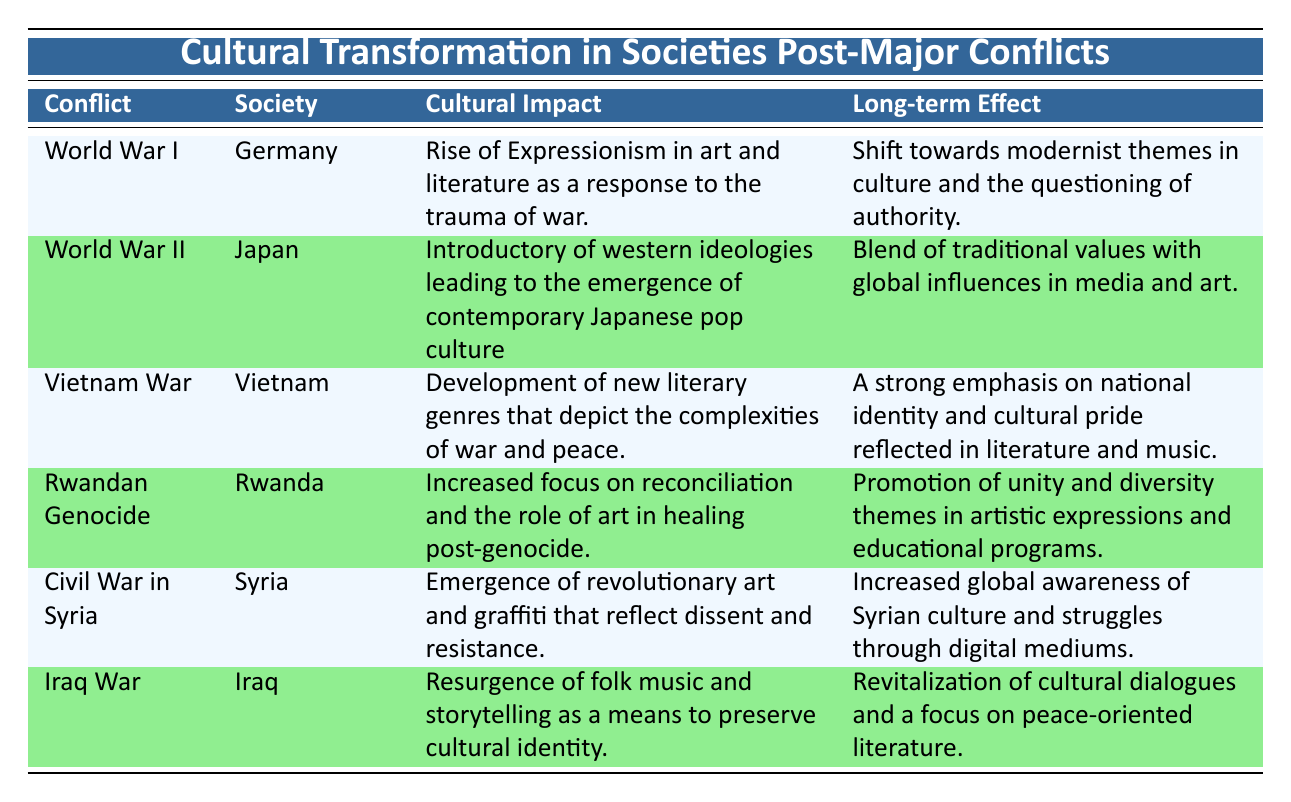What cultural impact was observed in Germany after World War I? The table states that the cultural impact in Germany after World War I was a rise of Expressionism in art and literature as a response to the trauma of war.
Answer: Rise of Expressionism in art and literature What long-term effect did the Vietnam War have on Vietnamese literature and music? According to the table, the long-term effect of the Vietnam War was a strong emphasis on national identity and cultural pride reflected in literature and music.
Answer: Strong emphasis on national identity and cultural pride Is it true that post-World War II Japan saw a blend of traditional values with global influences in media and art? The table clearly indicates that post-World War II Japan experienced a blend of traditional values with global influences in media and art.
Answer: Yes What was the cultural impact in Rwanda after the Rwandan Genocide? The table notes that there was an increased focus on reconciliation and the role of art in healing post-genocide in Rwanda.
Answer: Increased focus on reconciliation and the role of art in healing Which conflict resulted in the emergence of revolutionary art and graffiti in Syria? The table shows that the Civil War in Syria led to the emergence of revolutionary art and graffiti that reflect dissent and resistance.
Answer: Civil War in Syria What societal changes were noted in Iraq after the Iraq War? The table details that the cultural impact in Iraq following the Iraq War included a resurgence of folk music and storytelling as means to preserve cultural identity.
Answer: Resurgence of folk music and storytelling How does the cultural transformation after the Vietnam War compare to that of the Rwandan Genocide in terms of effects on national identity? The table indicates that both conflicts resulted in significant national identity transformations; Vietnam emphasized cultural pride, while Rwanda promoted unity and diversity, showing a common theme of reconstruction of identity post-conflict.
Answer: Both emphasized identity reconstruction; Vietnam on pride, Rwanda on unity Was the emergence of contemporary Japanese pop culture influenced by Western ideologies after World War II? Yes, the table states that the introduction of Western ideologies in Japan led to the emergence of contemporary Japanese pop culture.
Answer: Yes What was the common thread in the long-term effects of cultural transformations in Iraq and Syria? The table suggests that both Iraq and Syria's post-conflict long-term effects focused on revitalization—one towards cultural dialogues and the other towards global awareness—demonstrating a trend towards cultural re-engagement.
Answer: Focused on revitalization 